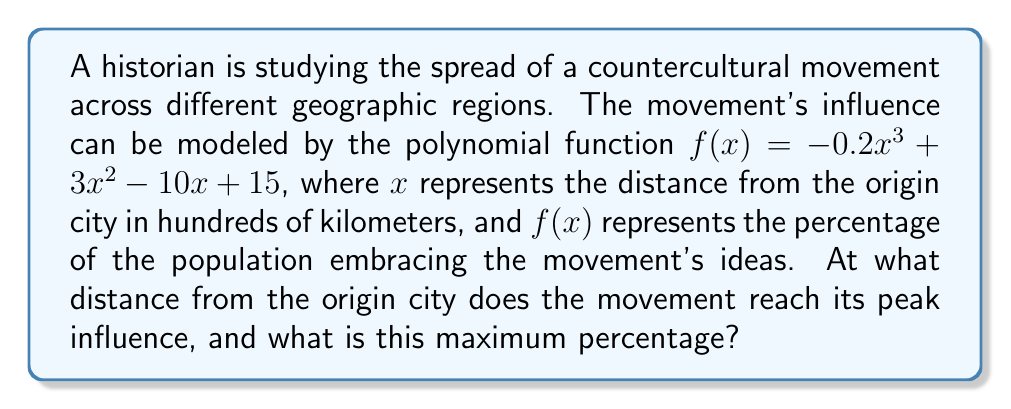Could you help me with this problem? To find the peak influence of the movement, we need to determine the maximum point of the polynomial function. This can be done by following these steps:

1) First, find the derivative of the function:
   $f'(x) = -0.6x^2 + 6x - 10$

2) Set the derivative equal to zero to find critical points:
   $-0.6x^2 + 6x - 10 = 0$

3) This is a quadratic equation. We can solve it using the quadratic formula:
   $x = \frac{-b \pm \sqrt{b^2 - 4ac}}{2a}$

   Where $a = -0.6$, $b = 6$, and $c = -10$

4) Plugging in these values:
   $x = \frac{-6 \pm \sqrt{36 - 4(-0.6)(-10)}}{2(-0.6)}$
   $= \frac{-6 \pm \sqrt{36 - 24}}{-1.2}$
   $= \frac{-6 \pm \sqrt{12}}{-1.2}$
   $= \frac{-6 \pm 2\sqrt{3}}{-1.2}$

5) This gives us two solutions:
   $x_1 = \frac{-6 + 2\sqrt{3}}{-1.2} = 5 - \frac{\sqrt{3}}{0.6} \approx 2.13$
   $x_2 = \frac{-6 - 2\sqrt{3}}{-1.2} = 5 + \frac{\sqrt{3}}{0.6} \approx 7.87$

6) To determine which of these is the maximum, we can check the second derivative:
   $f''(x) = -1.2x + 6$

7) Evaluating $f''(x)$ at $x_1$:
   $f''(2.13) \approx -1.2(2.13) + 6 = 3.44 > 0$

   This confirms that $x_1 \approx 2.13$ is the maximum point.

8) To find the maximum percentage, we plug this x-value back into our original function:
   $f(2.13) = -0.2(2.13)^3 + 3(2.13)^2 - 10(2.13) + 15 \approx 17.89$

Therefore, the movement reaches its peak influence at approximately 213 km from the origin city, with about 17.89% of the population embracing the movement's ideas.
Answer: 213 km; 17.89% 